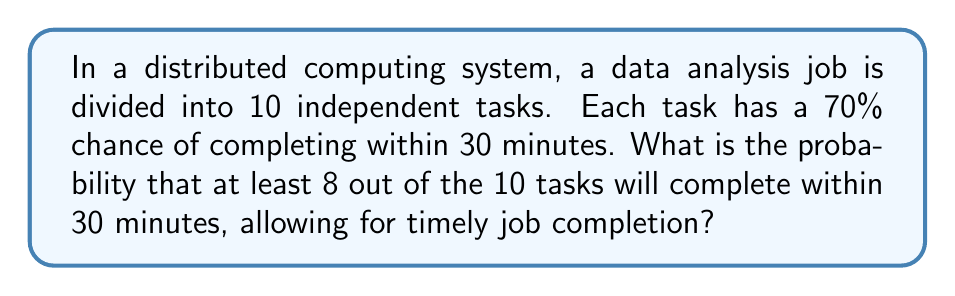Provide a solution to this math problem. Let's approach this step-by-step:

1) This is a binomial probability problem. We need to calculate the probability of 8, 9, or 10 tasks completing within 30 minutes.

2) Let's define our variables:
   $n = 10$ (total number of tasks)
   $p = 0.70$ (probability of a single task completing within 30 minutes)
   $q = 1 - p = 0.30$ (probability of a single task not completing within 30 minutes)

3) We need to calculate:
   $P(X \geq 8) = P(X = 8) + P(X = 9) + P(X = 10)$

4) The binomial probability formula is:
   $P(X = k) = \binom{n}{k} p^k q^{n-k}$

5) Let's calculate each probability:

   For 8 successes:
   $P(X = 8) = \binom{10}{8} (0.70)^8 (0.30)^2 = 45 \times 0.05764801 \times 0.09 = 0.2333604$

   For 9 successes:
   $P(X = 9) = \binom{10}{9} (0.70)^9 (0.30)^1 = 10 \times 0.04035361 \times 0.30 = 0.1210608$

   For 10 successes:
   $P(X = 10) = \binom{10}{10} (0.70)^{10} (0.30)^0 = 1 \times 0.02824752 \times 1 = 0.0282475$

6) Sum these probabilities:
   $P(X \geq 8) = 0.2333604 + 0.1210608 + 0.0282475 = 0.3826687$

Therefore, the probability of at least 8 out of 10 tasks completing within 30 minutes is approximately 0.3827 or 38.27%.
Answer: 0.3827 